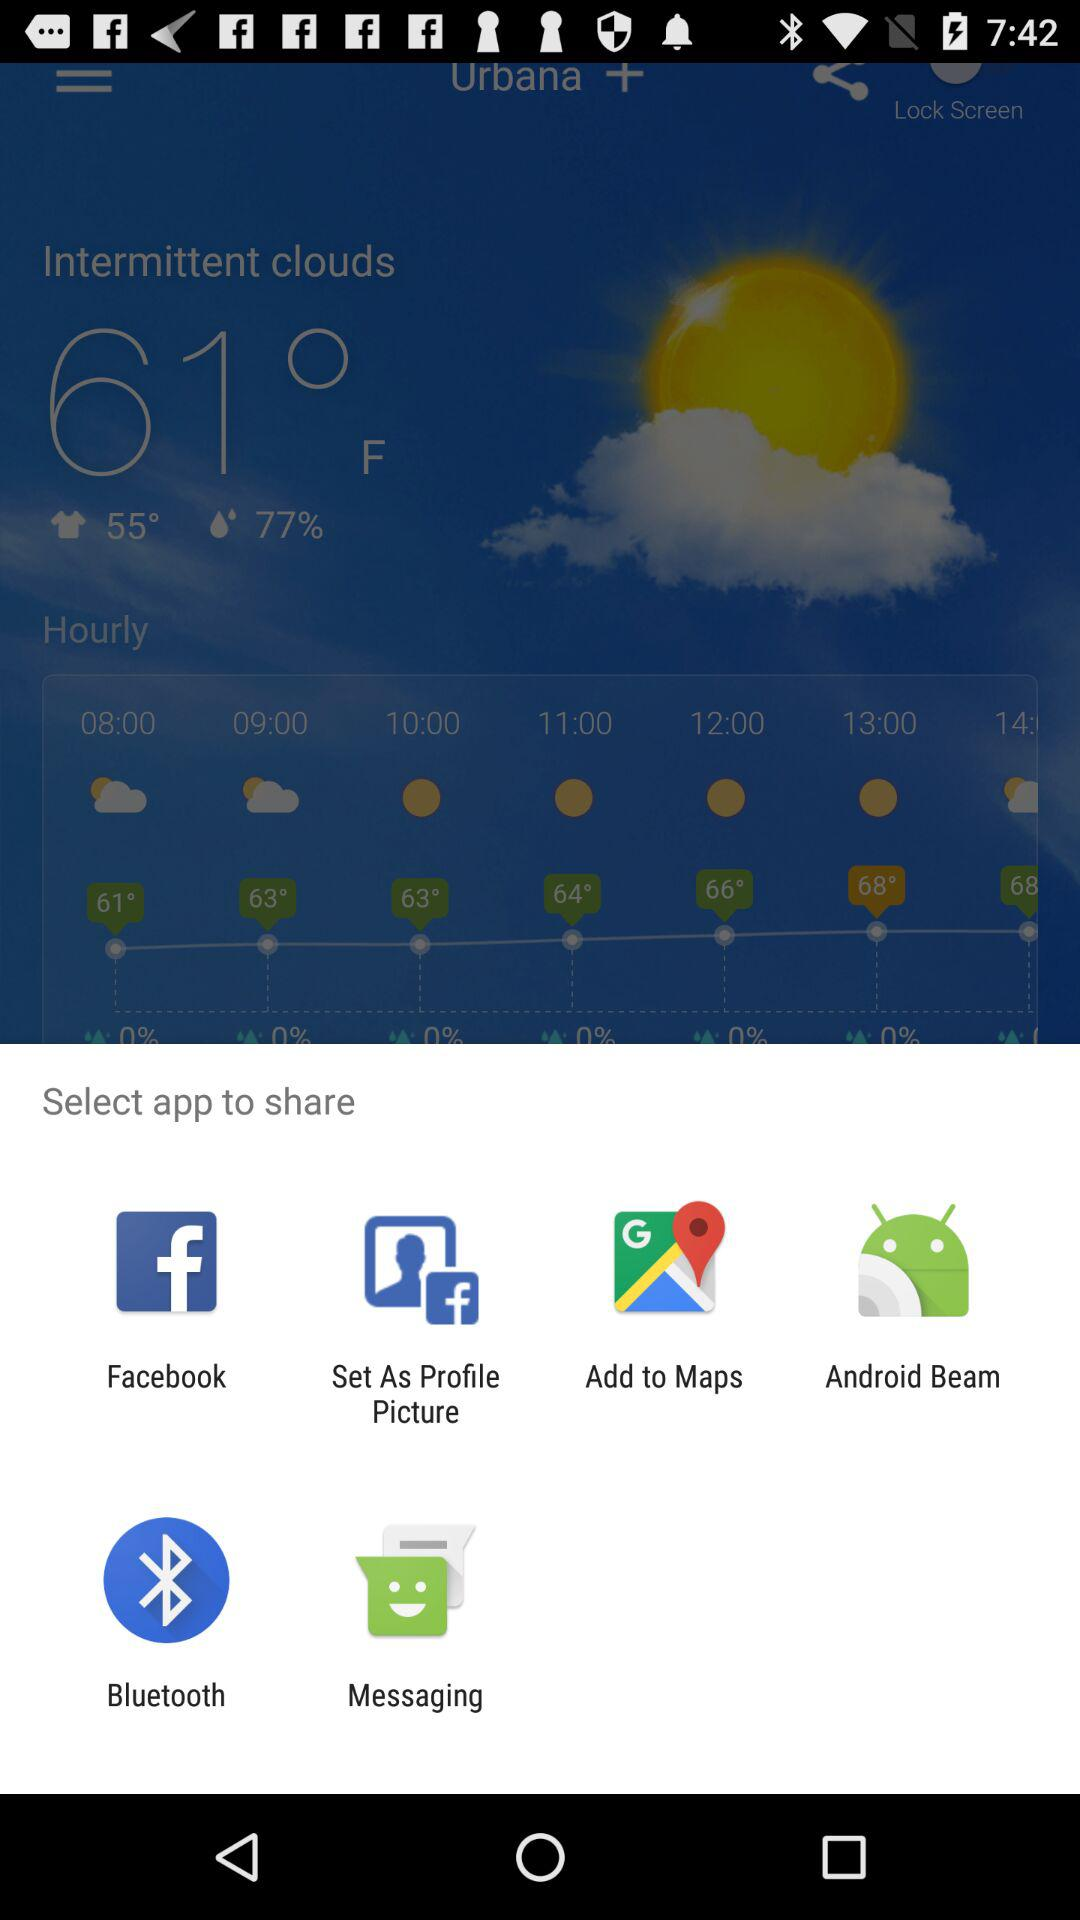How many hours are between 08:00 and 12:00?
Answer the question using a single word or phrase. 4 